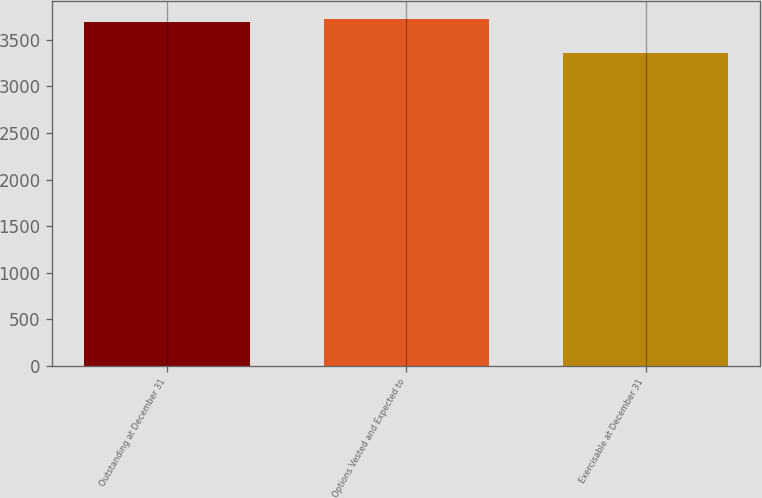Convert chart to OTSL. <chart><loc_0><loc_0><loc_500><loc_500><bar_chart><fcel>Outstanding at December 31<fcel>Options Vested and Expected to<fcel>Exercisable at December 31<nl><fcel>3691<fcel>3724.5<fcel>3356<nl></chart> 